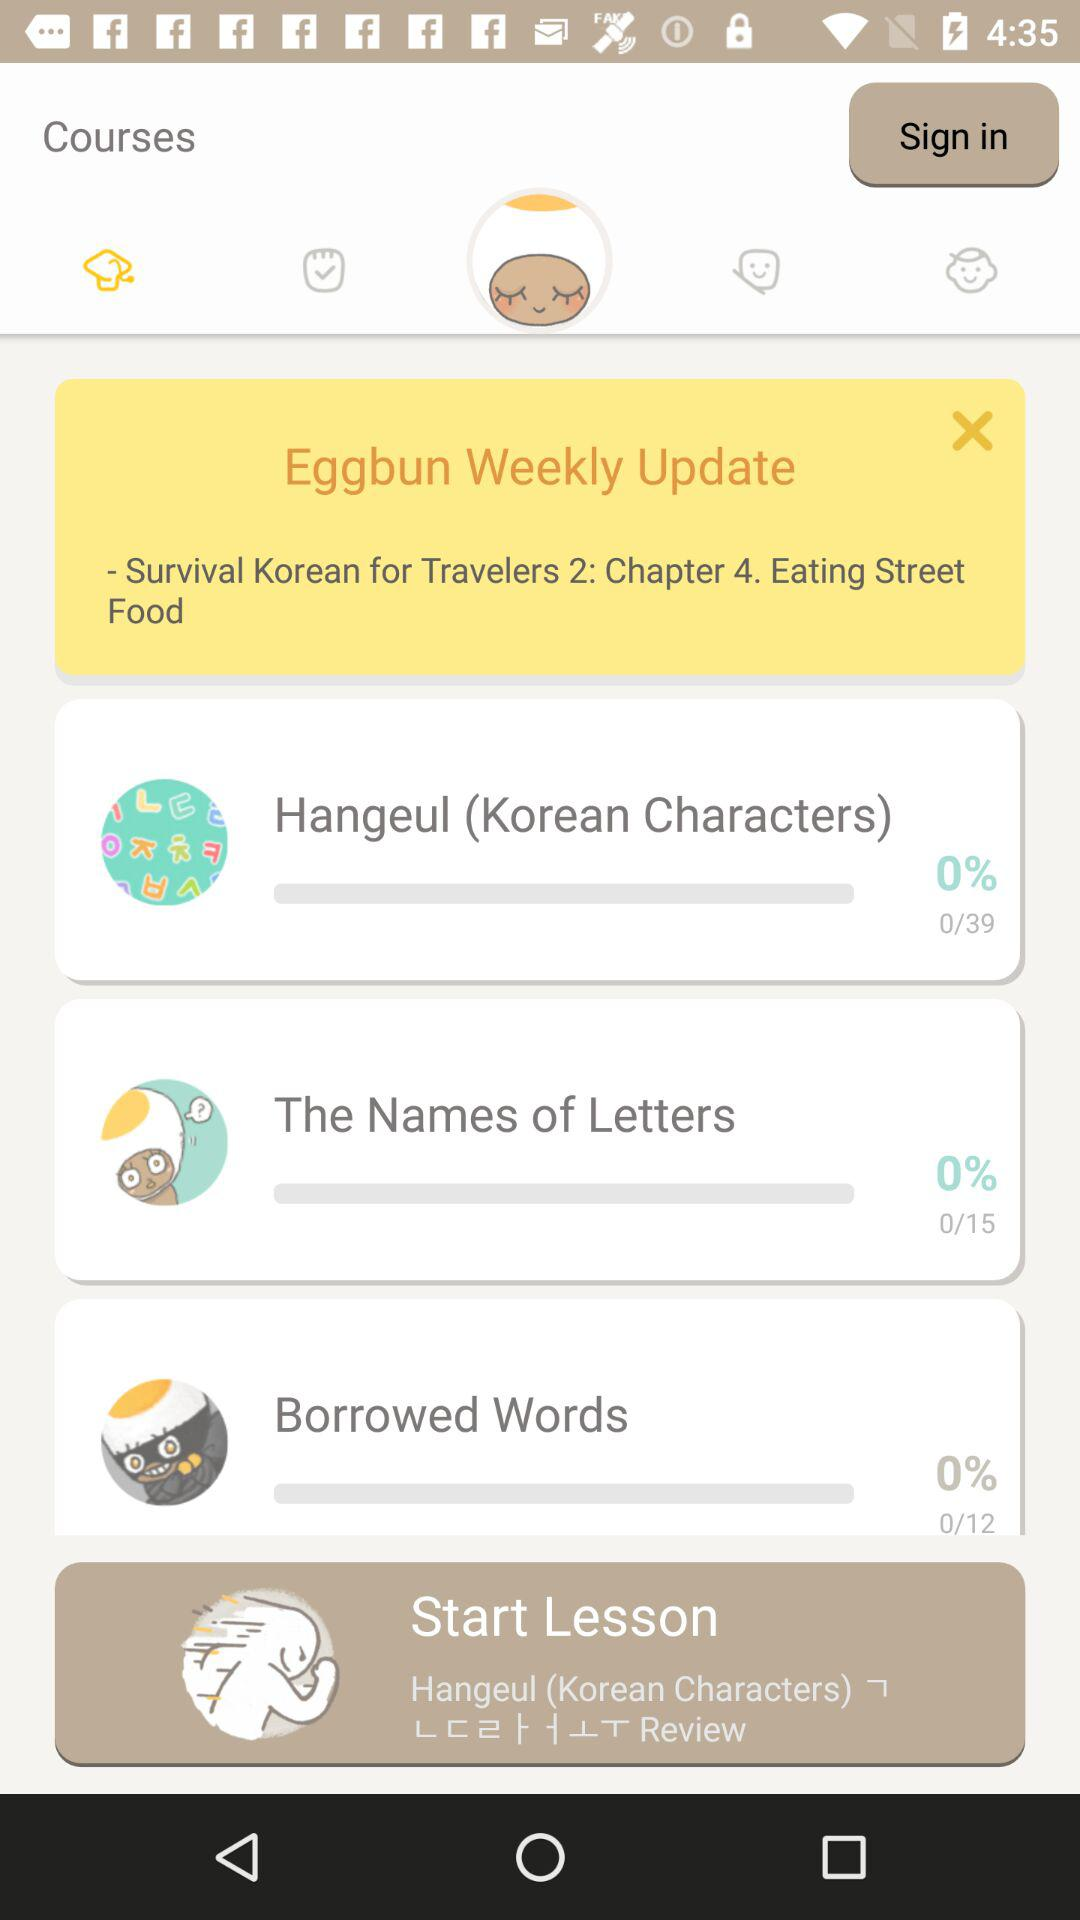What percentage is shown in "The Names of Letters"? The percentage shown in "The Names of Letters" is 0%. 